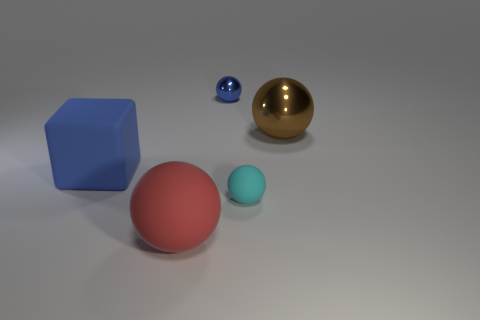Is the size of the red sphere the same as the blue thing that is in front of the brown metallic object?
Provide a succinct answer. Yes. Are there any red balls of the same size as the red rubber object?
Make the answer very short. No. What number of other things are made of the same material as the large red object?
Provide a succinct answer. 2. The object that is both left of the large brown shiny thing and on the right side of the tiny metallic object is what color?
Make the answer very short. Cyan. Are the blue object behind the large blue block and the big ball that is in front of the brown sphere made of the same material?
Make the answer very short. No. There is a metal object that is in front of the blue ball; does it have the same size as the small cyan matte ball?
Provide a short and direct response. No. Does the tiny metal ball have the same color as the large cube in front of the tiny blue metallic ball?
Ensure brevity in your answer.  Yes. What is the shape of the big object that is the same color as the tiny shiny sphere?
Offer a very short reply. Cube. What is the shape of the blue matte thing?
Make the answer very short. Cube. Is the color of the small metal object the same as the big matte block?
Offer a terse response. Yes. 